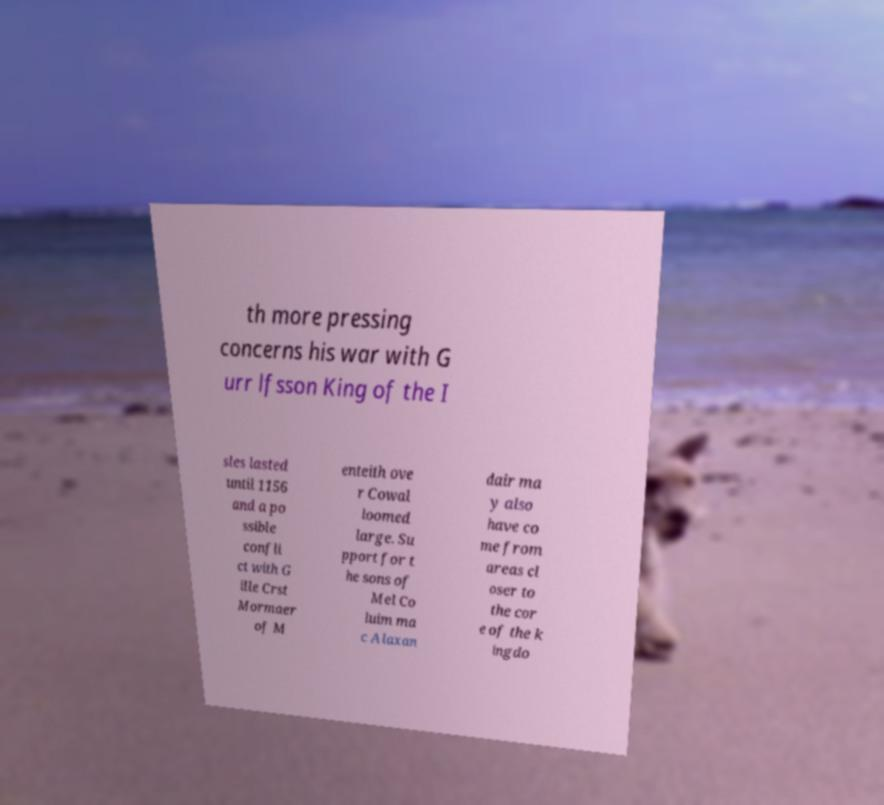Can you accurately transcribe the text from the provided image for me? th more pressing concerns his war with G urr lfsson King of the I sles lasted until 1156 and a po ssible confli ct with G ille Crst Mormaer of M enteith ove r Cowal loomed large. Su pport for t he sons of Mel Co luim ma c Alaxan dair ma y also have co me from areas cl oser to the cor e of the k ingdo 